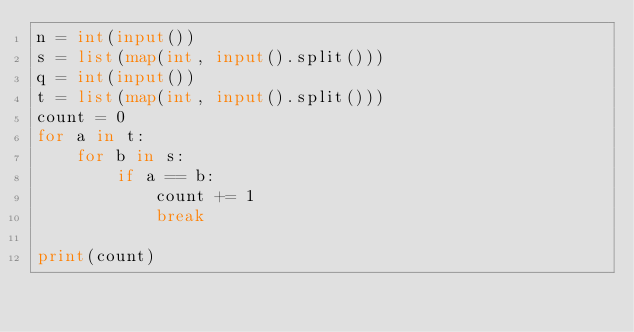<code> <loc_0><loc_0><loc_500><loc_500><_Python_>n = int(input())
s = list(map(int, input().split()))
q = int(input())
t = list(map(int, input().split()))
count = 0
for a in t:
    for b in s:
        if a == b:
            count += 1
            break

print(count)

</code> 